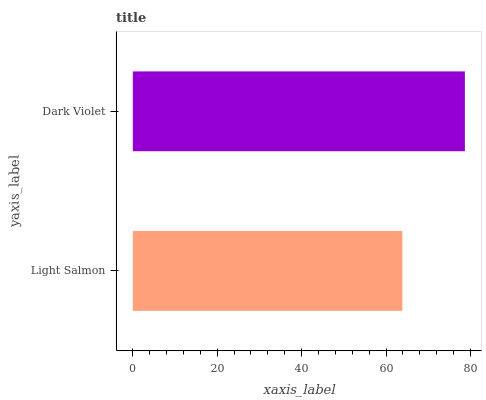Is Light Salmon the minimum?
Answer yes or no. Yes. Is Dark Violet the maximum?
Answer yes or no. Yes. Is Dark Violet the minimum?
Answer yes or no. No. Is Dark Violet greater than Light Salmon?
Answer yes or no. Yes. Is Light Salmon less than Dark Violet?
Answer yes or no. Yes. Is Light Salmon greater than Dark Violet?
Answer yes or no. No. Is Dark Violet less than Light Salmon?
Answer yes or no. No. Is Dark Violet the high median?
Answer yes or no. Yes. Is Light Salmon the low median?
Answer yes or no. Yes. Is Light Salmon the high median?
Answer yes or no. No. Is Dark Violet the low median?
Answer yes or no. No. 